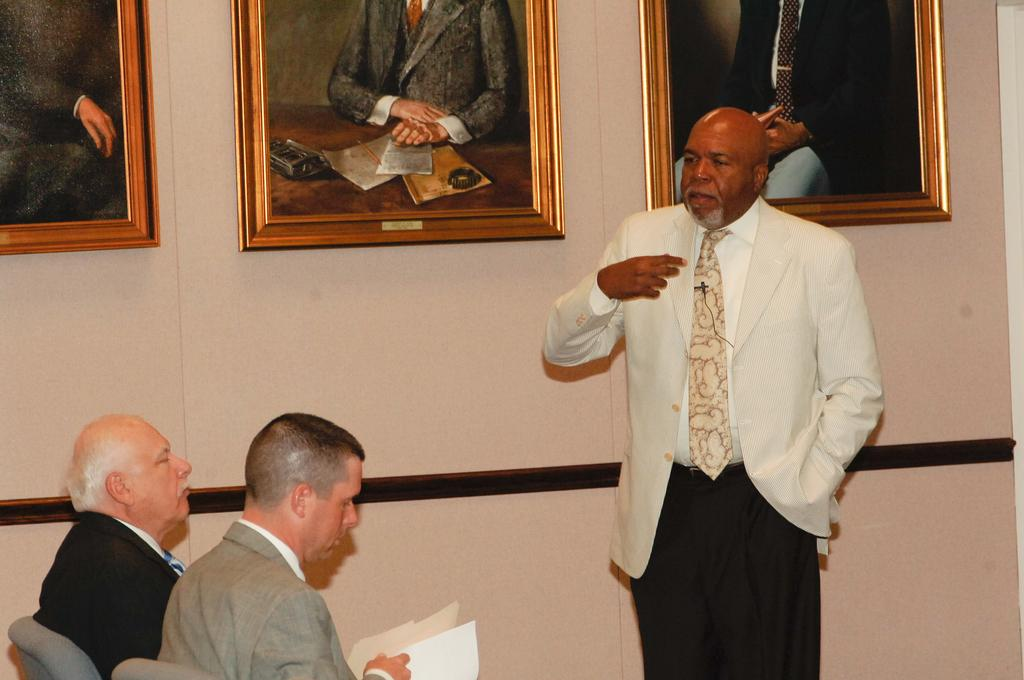How many people are in the image? There are people in the image, but the exact number is not specified. What are some of the people in the image doing? Some people in the image are sitting. What can be seen on the wall in the image? There is a wall with photo frames in the image. How many ladybugs can be seen crawling on the wall in the image? There are no ladybugs visible in the image; only people, sitting people, and a wall with photo frames are mentioned. 